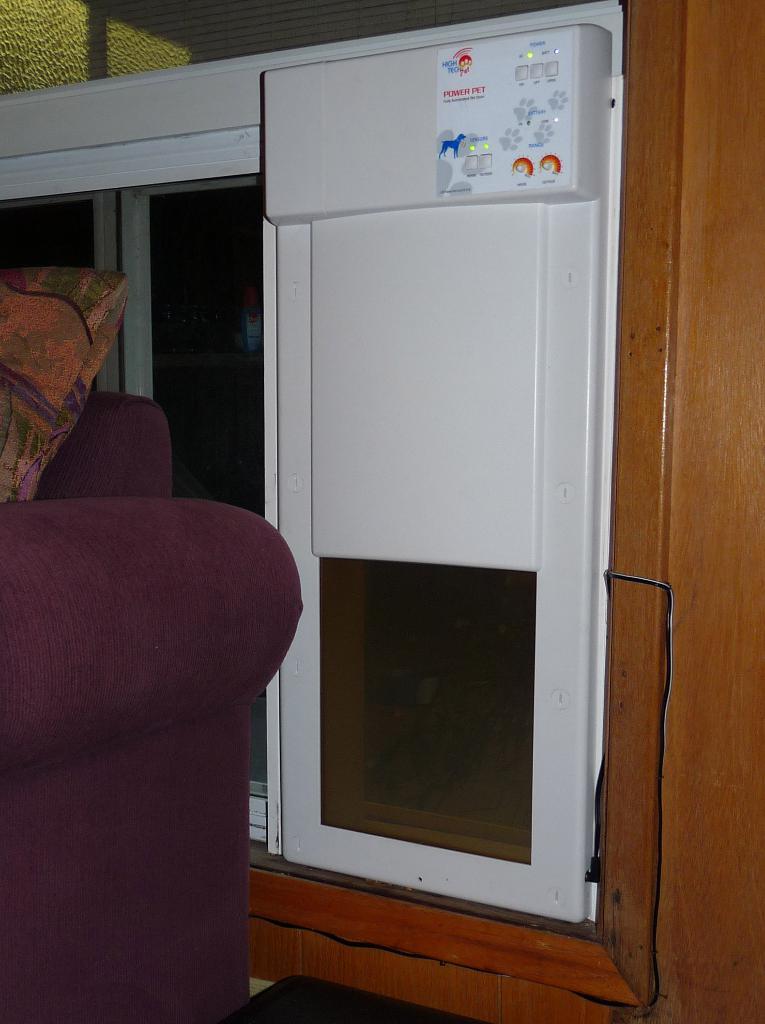What brand is the pet door?
Your response must be concise. Unanswerable. 